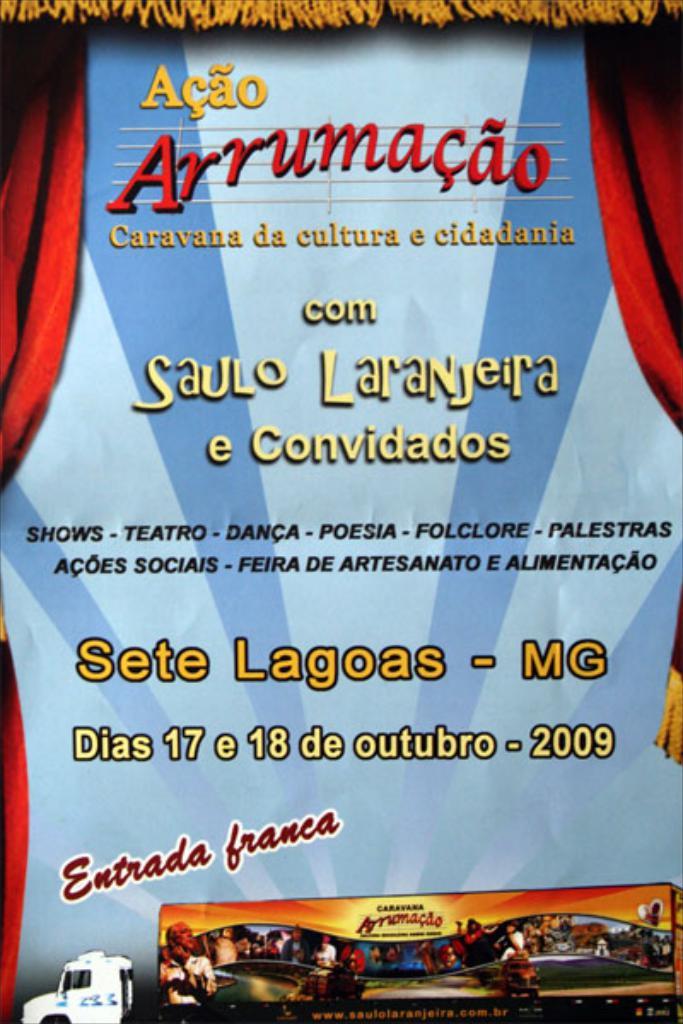What year is shown?
Make the answer very short. 2009. 